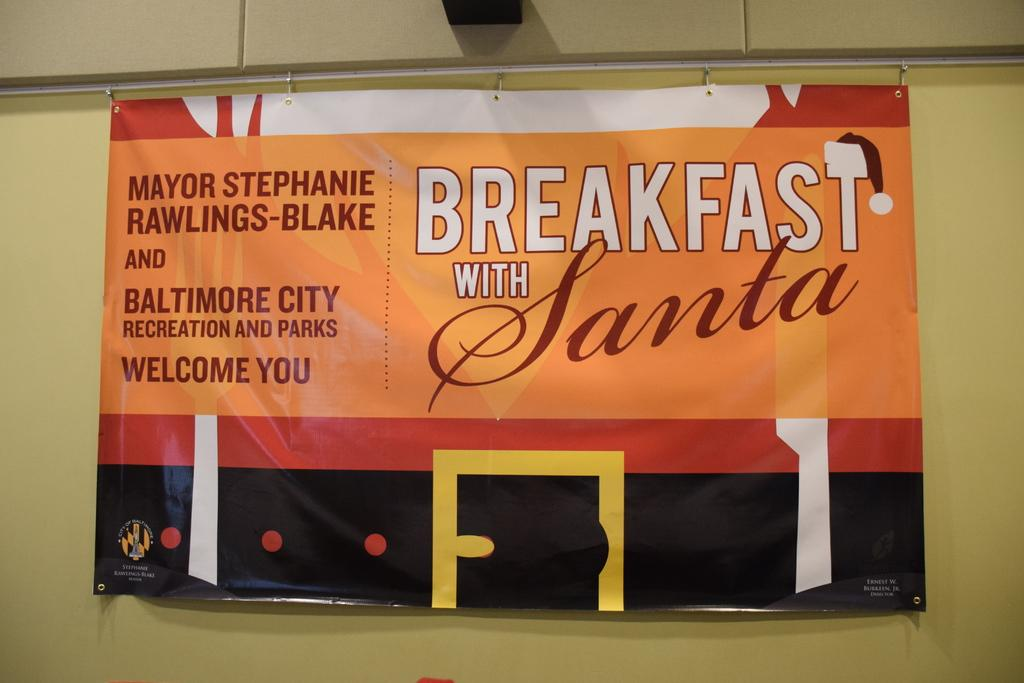<image>
Describe the image concisely. the word breakfast is on a sign on the wall 